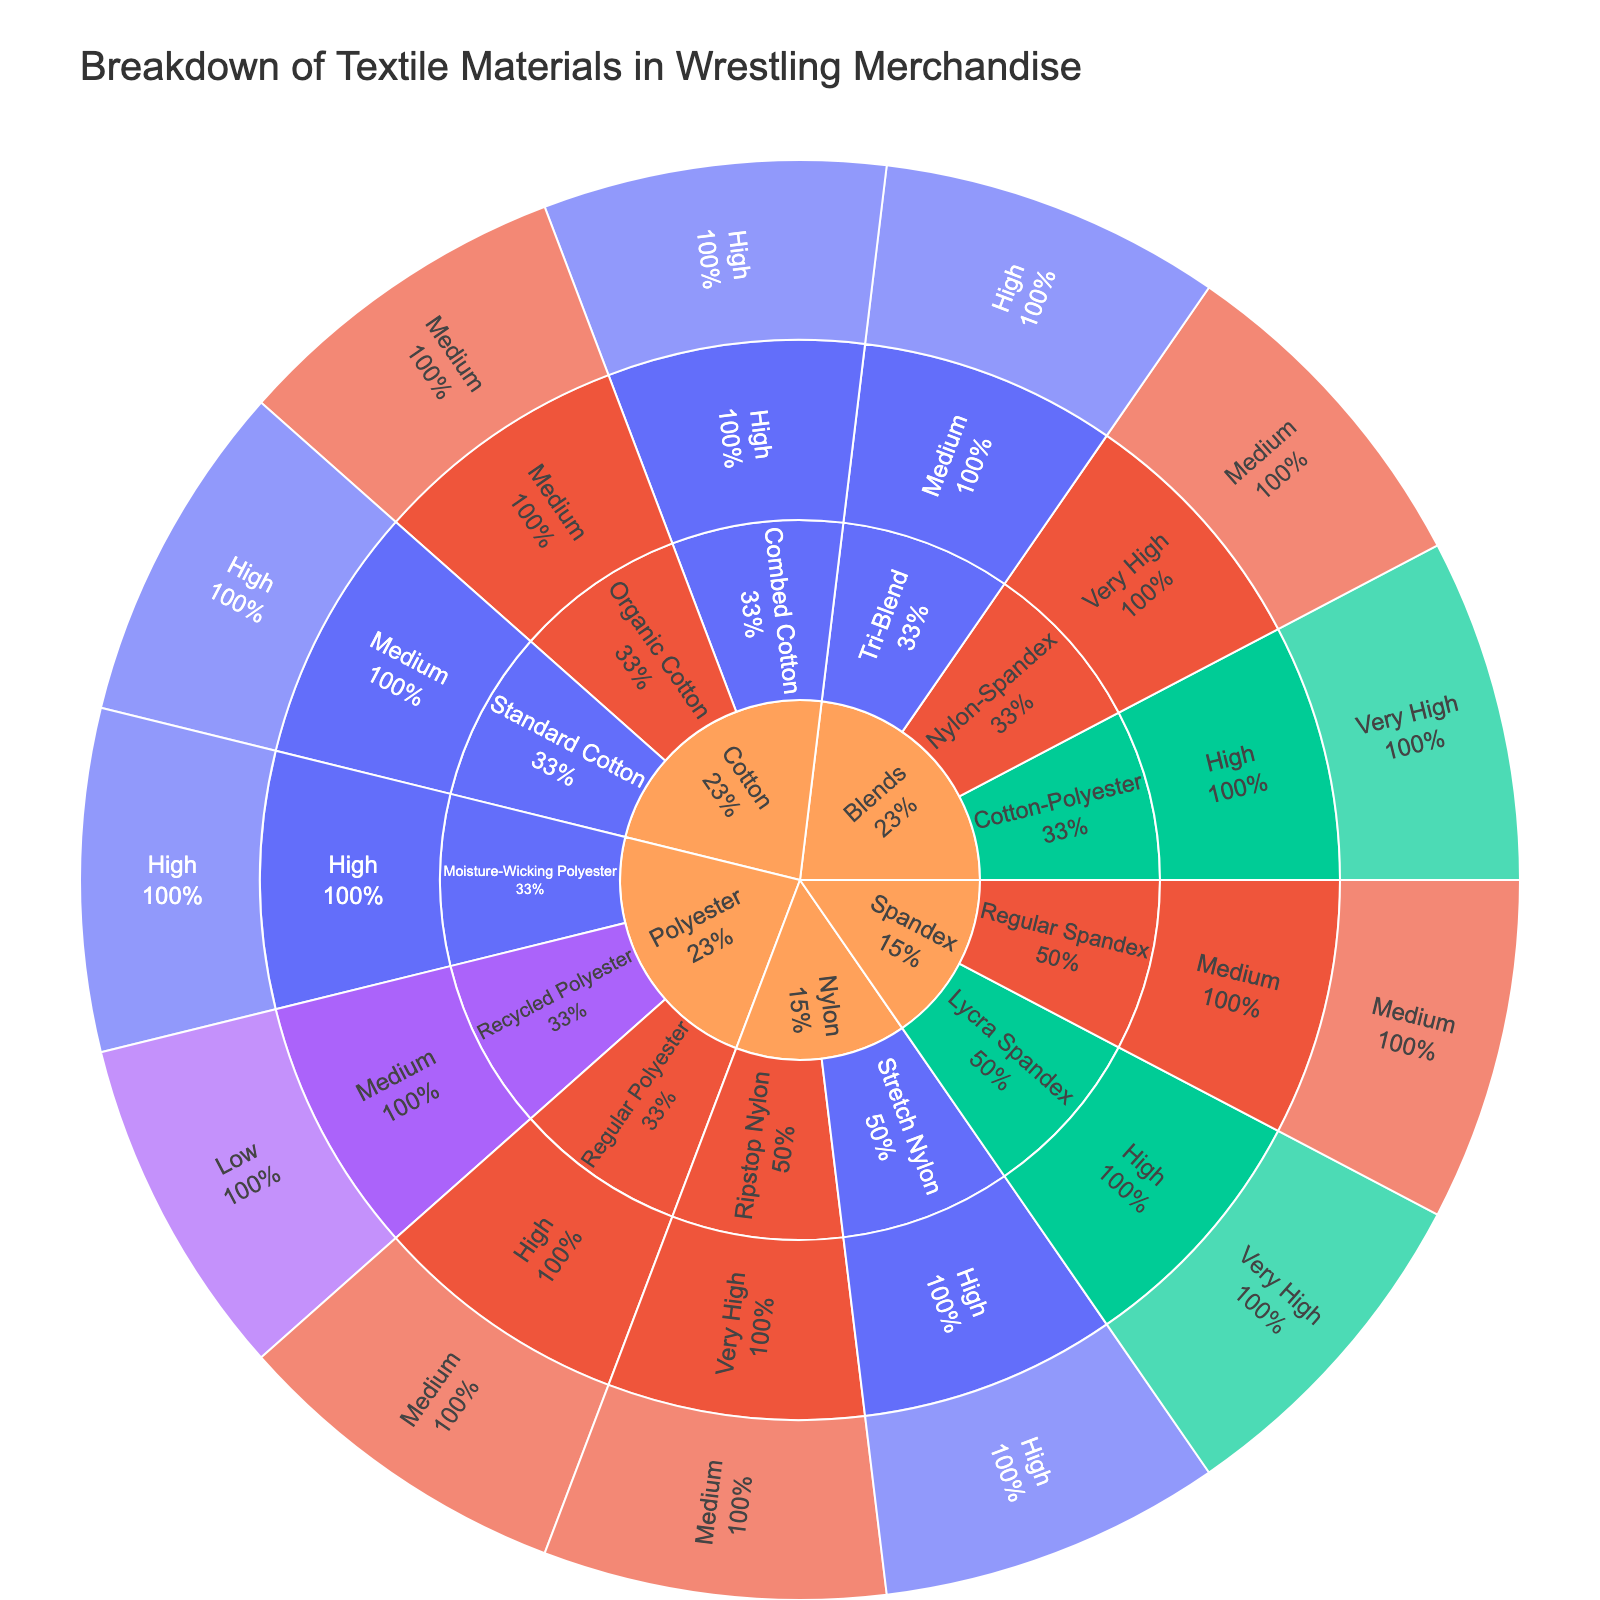what are the categories of textile materials used in wrestling merchandise? The categories can be directly identified from the top level of the sunburst plot. These categories form the first ring in the sunburst.
Answer: Cotton, Polyester, Nylon, Spandex, Blends Which material has the highest popularity within the Polyester category? Looking at the second ring within the Polyester section of the sunburst plot and examining their popularity levels, Moisture-Wicking Polyester stands out.
Answer: Moisture-Wicking Polyester What are the durability levels of materials categorized under Nylon? Locate the Nylon section of the sunburst plot and observe the third ring, which shows durability levels for its materials. The materials under Nylon show the durability levels of "Very High" and "High".
Answer: Very High, High How many materials have a durability level of "Medium"? By examining the third ring across all categories in the sunburst plot, the number of slices labeled with "Medium" durability can be counted. These include Standard Cotton, Organic Cotton, Recycled Polyester, Regular Spandex, Tri-Blend.
Answer: 5 What are the most popular and the least popular materials in the sunburst plot? Inspect the fourth ring of the sunburst plot for the popularity levels of all materials. "Very High" indicates the most popular, while "Low" suggests the least popular. The materials with these labels can be identified.
Answer: Most popular: Lycra Spandex; Least popular: Recycled Polyester Which has a higher percentage of "High" popularity: Cotton or Spandex? Compare the portions of the fourth ring under "High" popularity in the Cotton and Spandex sections. Both categories should be examined for the number of materials with "High" popularity and their respective proportions.
Answer: Cotton How does the durability of blends compare to those of other categories? Observe the blend section and the other categories in the third ring of the sunburst plot to compare the indicated durability levels for each. Blends have materials with "High" and "Very High" durability, while other categories vary.
Answer: Blends typically have higher durability Which category contains materials with a "Low" popularity rating? Check the fourth ring across all categories to find materials with a "Low" popularity rating. The category "Polyester" has a material (Recycled Polyester) with "Low" popularity.
Answer: Polyester Is there any material with both very high durability and popularity? Examine the sunburst plot for materials with "Very High" durability (third ring) and "Very High" popularity (fourth ring). Nylon-Spandex under Blends fits this criterion.
Answer: Nylon-Spandex Compare the popularity of Combed Cotton and Tri-Blend. Which is higher? Look at the plot sections for both Combed Cotton and Tri-Blend to find their popularity levels in the outer ring. Combed Cotton has "High" popularity, while Tri-Blend has "High" popularity. Hence, they are equal.
Answer: Equal 